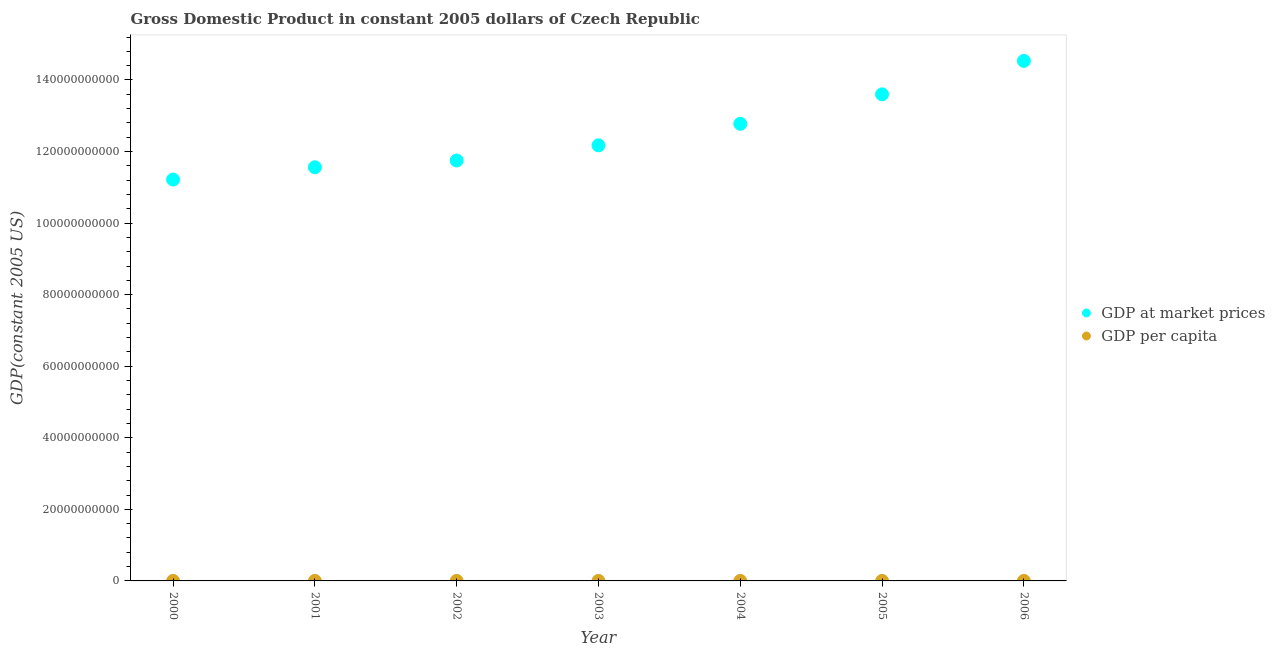How many different coloured dotlines are there?
Give a very brief answer. 2. Is the number of dotlines equal to the number of legend labels?
Your answer should be very brief. Yes. What is the gdp per capita in 2003?
Ensure brevity in your answer.  1.19e+04. Across all years, what is the maximum gdp at market prices?
Provide a succinct answer. 1.45e+11. Across all years, what is the minimum gdp per capita?
Make the answer very short. 1.09e+04. In which year was the gdp per capita maximum?
Your response must be concise. 2006. What is the total gdp at market prices in the graph?
Provide a short and direct response. 8.76e+11. What is the difference between the gdp at market prices in 2001 and that in 2006?
Provide a succinct answer. -2.97e+1. What is the difference between the gdp at market prices in 2006 and the gdp per capita in 2005?
Offer a terse response. 1.45e+11. What is the average gdp at market prices per year?
Provide a succinct answer. 1.25e+11. In the year 2006, what is the difference between the gdp at market prices and gdp per capita?
Your answer should be very brief. 1.45e+11. What is the ratio of the gdp per capita in 2002 to that in 2005?
Give a very brief answer. 0.87. What is the difference between the highest and the second highest gdp at market prices?
Your answer should be compact. 9.35e+09. What is the difference between the highest and the lowest gdp per capita?
Offer a very short reply. 3256.3. Is the gdp at market prices strictly less than the gdp per capita over the years?
Offer a very short reply. No. How many dotlines are there?
Give a very brief answer. 2. How many years are there in the graph?
Offer a very short reply. 7. What is the difference between two consecutive major ticks on the Y-axis?
Provide a succinct answer. 2.00e+1. How many legend labels are there?
Give a very brief answer. 2. What is the title of the graph?
Your response must be concise. Gross Domestic Product in constant 2005 dollars of Czech Republic. What is the label or title of the Y-axis?
Your response must be concise. GDP(constant 2005 US). What is the GDP(constant 2005 US) of GDP at market prices in 2000?
Offer a terse response. 1.12e+11. What is the GDP(constant 2005 US) in GDP per capita in 2000?
Give a very brief answer. 1.09e+04. What is the GDP(constant 2005 US) in GDP at market prices in 2001?
Give a very brief answer. 1.16e+11. What is the GDP(constant 2005 US) of GDP per capita in 2001?
Keep it short and to the point. 1.13e+04. What is the GDP(constant 2005 US) of GDP at market prices in 2002?
Provide a short and direct response. 1.18e+11. What is the GDP(constant 2005 US) of GDP per capita in 2002?
Keep it short and to the point. 1.15e+04. What is the GDP(constant 2005 US) of GDP at market prices in 2003?
Your answer should be very brief. 1.22e+11. What is the GDP(constant 2005 US) in GDP per capita in 2003?
Keep it short and to the point. 1.19e+04. What is the GDP(constant 2005 US) of GDP at market prices in 2004?
Ensure brevity in your answer.  1.28e+11. What is the GDP(constant 2005 US) of GDP per capita in 2004?
Make the answer very short. 1.25e+04. What is the GDP(constant 2005 US) in GDP at market prices in 2005?
Provide a succinct answer. 1.36e+11. What is the GDP(constant 2005 US) in GDP per capita in 2005?
Your answer should be very brief. 1.33e+04. What is the GDP(constant 2005 US) of GDP at market prices in 2006?
Provide a short and direct response. 1.45e+11. What is the GDP(constant 2005 US) of GDP per capita in 2006?
Give a very brief answer. 1.42e+04. Across all years, what is the maximum GDP(constant 2005 US) in GDP at market prices?
Give a very brief answer. 1.45e+11. Across all years, what is the maximum GDP(constant 2005 US) of GDP per capita?
Keep it short and to the point. 1.42e+04. Across all years, what is the minimum GDP(constant 2005 US) of GDP at market prices?
Keep it short and to the point. 1.12e+11. Across all years, what is the minimum GDP(constant 2005 US) in GDP per capita?
Offer a terse response. 1.09e+04. What is the total GDP(constant 2005 US) in GDP at market prices in the graph?
Your answer should be compact. 8.76e+11. What is the total GDP(constant 2005 US) in GDP per capita in the graph?
Provide a short and direct response. 8.58e+04. What is the difference between the GDP(constant 2005 US) of GDP at market prices in 2000 and that in 2001?
Offer a terse response. -3.42e+09. What is the difference between the GDP(constant 2005 US) of GDP per capita in 2000 and that in 2001?
Give a very brief answer. -376.23. What is the difference between the GDP(constant 2005 US) in GDP at market prices in 2000 and that in 2002?
Ensure brevity in your answer.  -5.33e+09. What is the difference between the GDP(constant 2005 US) of GDP per capita in 2000 and that in 2002?
Offer a very short reply. -584.79. What is the difference between the GDP(constant 2005 US) in GDP at market prices in 2000 and that in 2003?
Provide a succinct answer. -9.56e+09. What is the difference between the GDP(constant 2005 US) of GDP per capita in 2000 and that in 2003?
Your answer should be compact. -1003.27. What is the difference between the GDP(constant 2005 US) of GDP at market prices in 2000 and that in 2004?
Offer a terse response. -1.56e+1. What is the difference between the GDP(constant 2005 US) in GDP per capita in 2000 and that in 2004?
Your answer should be compact. -1590.28. What is the difference between the GDP(constant 2005 US) in GDP at market prices in 2000 and that in 2005?
Your answer should be very brief. -2.38e+1. What is the difference between the GDP(constant 2005 US) in GDP per capita in 2000 and that in 2005?
Provide a short and direct response. -2379. What is the difference between the GDP(constant 2005 US) in GDP at market prices in 2000 and that in 2006?
Provide a succinct answer. -3.32e+1. What is the difference between the GDP(constant 2005 US) in GDP per capita in 2000 and that in 2006?
Keep it short and to the point. -3256.3. What is the difference between the GDP(constant 2005 US) in GDP at market prices in 2001 and that in 2002?
Your response must be concise. -1.90e+09. What is the difference between the GDP(constant 2005 US) in GDP per capita in 2001 and that in 2002?
Offer a very short reply. -208.56. What is the difference between the GDP(constant 2005 US) of GDP at market prices in 2001 and that in 2003?
Provide a short and direct response. -6.14e+09. What is the difference between the GDP(constant 2005 US) in GDP per capita in 2001 and that in 2003?
Keep it short and to the point. -627.04. What is the difference between the GDP(constant 2005 US) in GDP at market prices in 2001 and that in 2004?
Give a very brief answer. -1.22e+1. What is the difference between the GDP(constant 2005 US) of GDP per capita in 2001 and that in 2004?
Provide a succinct answer. -1214.05. What is the difference between the GDP(constant 2005 US) in GDP at market prices in 2001 and that in 2005?
Keep it short and to the point. -2.04e+1. What is the difference between the GDP(constant 2005 US) in GDP per capita in 2001 and that in 2005?
Offer a terse response. -2002.76. What is the difference between the GDP(constant 2005 US) in GDP at market prices in 2001 and that in 2006?
Keep it short and to the point. -2.97e+1. What is the difference between the GDP(constant 2005 US) of GDP per capita in 2001 and that in 2006?
Give a very brief answer. -2880.07. What is the difference between the GDP(constant 2005 US) of GDP at market prices in 2002 and that in 2003?
Your answer should be compact. -4.23e+09. What is the difference between the GDP(constant 2005 US) of GDP per capita in 2002 and that in 2003?
Make the answer very short. -418.48. What is the difference between the GDP(constant 2005 US) of GDP at market prices in 2002 and that in 2004?
Make the answer very short. -1.03e+1. What is the difference between the GDP(constant 2005 US) in GDP per capita in 2002 and that in 2004?
Your answer should be very brief. -1005.49. What is the difference between the GDP(constant 2005 US) of GDP at market prices in 2002 and that in 2005?
Ensure brevity in your answer.  -1.85e+1. What is the difference between the GDP(constant 2005 US) in GDP per capita in 2002 and that in 2005?
Provide a short and direct response. -1794.21. What is the difference between the GDP(constant 2005 US) of GDP at market prices in 2002 and that in 2006?
Offer a terse response. -2.78e+1. What is the difference between the GDP(constant 2005 US) of GDP per capita in 2002 and that in 2006?
Your response must be concise. -2671.51. What is the difference between the GDP(constant 2005 US) in GDP at market prices in 2003 and that in 2004?
Give a very brief answer. -6.02e+09. What is the difference between the GDP(constant 2005 US) in GDP per capita in 2003 and that in 2004?
Make the answer very short. -587.01. What is the difference between the GDP(constant 2005 US) of GDP at market prices in 2003 and that in 2005?
Offer a very short reply. -1.43e+1. What is the difference between the GDP(constant 2005 US) of GDP per capita in 2003 and that in 2005?
Keep it short and to the point. -1375.73. What is the difference between the GDP(constant 2005 US) of GDP at market prices in 2003 and that in 2006?
Make the answer very short. -2.36e+1. What is the difference between the GDP(constant 2005 US) in GDP per capita in 2003 and that in 2006?
Your answer should be very brief. -2253.04. What is the difference between the GDP(constant 2005 US) of GDP at market prices in 2004 and that in 2005?
Offer a very short reply. -8.23e+09. What is the difference between the GDP(constant 2005 US) of GDP per capita in 2004 and that in 2005?
Offer a very short reply. -788.72. What is the difference between the GDP(constant 2005 US) in GDP at market prices in 2004 and that in 2006?
Keep it short and to the point. -1.76e+1. What is the difference between the GDP(constant 2005 US) of GDP per capita in 2004 and that in 2006?
Your answer should be compact. -1666.03. What is the difference between the GDP(constant 2005 US) in GDP at market prices in 2005 and that in 2006?
Your response must be concise. -9.35e+09. What is the difference between the GDP(constant 2005 US) in GDP per capita in 2005 and that in 2006?
Ensure brevity in your answer.  -877.31. What is the difference between the GDP(constant 2005 US) of GDP at market prices in 2000 and the GDP(constant 2005 US) of GDP per capita in 2001?
Your response must be concise. 1.12e+11. What is the difference between the GDP(constant 2005 US) in GDP at market prices in 2000 and the GDP(constant 2005 US) in GDP per capita in 2002?
Make the answer very short. 1.12e+11. What is the difference between the GDP(constant 2005 US) of GDP at market prices in 2000 and the GDP(constant 2005 US) of GDP per capita in 2003?
Ensure brevity in your answer.  1.12e+11. What is the difference between the GDP(constant 2005 US) of GDP at market prices in 2000 and the GDP(constant 2005 US) of GDP per capita in 2004?
Keep it short and to the point. 1.12e+11. What is the difference between the GDP(constant 2005 US) in GDP at market prices in 2000 and the GDP(constant 2005 US) in GDP per capita in 2005?
Provide a succinct answer. 1.12e+11. What is the difference between the GDP(constant 2005 US) of GDP at market prices in 2000 and the GDP(constant 2005 US) of GDP per capita in 2006?
Offer a very short reply. 1.12e+11. What is the difference between the GDP(constant 2005 US) of GDP at market prices in 2001 and the GDP(constant 2005 US) of GDP per capita in 2002?
Your response must be concise. 1.16e+11. What is the difference between the GDP(constant 2005 US) of GDP at market prices in 2001 and the GDP(constant 2005 US) of GDP per capita in 2003?
Provide a succinct answer. 1.16e+11. What is the difference between the GDP(constant 2005 US) in GDP at market prices in 2001 and the GDP(constant 2005 US) in GDP per capita in 2004?
Make the answer very short. 1.16e+11. What is the difference between the GDP(constant 2005 US) of GDP at market prices in 2001 and the GDP(constant 2005 US) of GDP per capita in 2005?
Provide a short and direct response. 1.16e+11. What is the difference between the GDP(constant 2005 US) of GDP at market prices in 2001 and the GDP(constant 2005 US) of GDP per capita in 2006?
Your response must be concise. 1.16e+11. What is the difference between the GDP(constant 2005 US) in GDP at market prices in 2002 and the GDP(constant 2005 US) in GDP per capita in 2003?
Your response must be concise. 1.18e+11. What is the difference between the GDP(constant 2005 US) in GDP at market prices in 2002 and the GDP(constant 2005 US) in GDP per capita in 2004?
Provide a short and direct response. 1.18e+11. What is the difference between the GDP(constant 2005 US) of GDP at market prices in 2002 and the GDP(constant 2005 US) of GDP per capita in 2005?
Provide a short and direct response. 1.18e+11. What is the difference between the GDP(constant 2005 US) in GDP at market prices in 2002 and the GDP(constant 2005 US) in GDP per capita in 2006?
Offer a very short reply. 1.18e+11. What is the difference between the GDP(constant 2005 US) in GDP at market prices in 2003 and the GDP(constant 2005 US) in GDP per capita in 2004?
Your response must be concise. 1.22e+11. What is the difference between the GDP(constant 2005 US) of GDP at market prices in 2003 and the GDP(constant 2005 US) of GDP per capita in 2005?
Give a very brief answer. 1.22e+11. What is the difference between the GDP(constant 2005 US) of GDP at market prices in 2003 and the GDP(constant 2005 US) of GDP per capita in 2006?
Your answer should be compact. 1.22e+11. What is the difference between the GDP(constant 2005 US) of GDP at market prices in 2004 and the GDP(constant 2005 US) of GDP per capita in 2005?
Keep it short and to the point. 1.28e+11. What is the difference between the GDP(constant 2005 US) of GDP at market prices in 2004 and the GDP(constant 2005 US) of GDP per capita in 2006?
Your answer should be compact. 1.28e+11. What is the difference between the GDP(constant 2005 US) in GDP at market prices in 2005 and the GDP(constant 2005 US) in GDP per capita in 2006?
Provide a succinct answer. 1.36e+11. What is the average GDP(constant 2005 US) in GDP at market prices per year?
Give a very brief answer. 1.25e+11. What is the average GDP(constant 2005 US) in GDP per capita per year?
Provide a succinct answer. 1.23e+04. In the year 2000, what is the difference between the GDP(constant 2005 US) of GDP at market prices and GDP(constant 2005 US) of GDP per capita?
Offer a terse response. 1.12e+11. In the year 2001, what is the difference between the GDP(constant 2005 US) in GDP at market prices and GDP(constant 2005 US) in GDP per capita?
Offer a very short reply. 1.16e+11. In the year 2002, what is the difference between the GDP(constant 2005 US) of GDP at market prices and GDP(constant 2005 US) of GDP per capita?
Provide a succinct answer. 1.18e+11. In the year 2003, what is the difference between the GDP(constant 2005 US) in GDP at market prices and GDP(constant 2005 US) in GDP per capita?
Keep it short and to the point. 1.22e+11. In the year 2004, what is the difference between the GDP(constant 2005 US) in GDP at market prices and GDP(constant 2005 US) in GDP per capita?
Your answer should be compact. 1.28e+11. In the year 2005, what is the difference between the GDP(constant 2005 US) in GDP at market prices and GDP(constant 2005 US) in GDP per capita?
Offer a terse response. 1.36e+11. In the year 2006, what is the difference between the GDP(constant 2005 US) in GDP at market prices and GDP(constant 2005 US) in GDP per capita?
Ensure brevity in your answer.  1.45e+11. What is the ratio of the GDP(constant 2005 US) in GDP at market prices in 2000 to that in 2001?
Offer a very short reply. 0.97. What is the ratio of the GDP(constant 2005 US) in GDP per capita in 2000 to that in 2001?
Give a very brief answer. 0.97. What is the ratio of the GDP(constant 2005 US) of GDP at market prices in 2000 to that in 2002?
Offer a very short reply. 0.95. What is the ratio of the GDP(constant 2005 US) of GDP per capita in 2000 to that in 2002?
Your response must be concise. 0.95. What is the ratio of the GDP(constant 2005 US) of GDP at market prices in 2000 to that in 2003?
Ensure brevity in your answer.  0.92. What is the ratio of the GDP(constant 2005 US) in GDP per capita in 2000 to that in 2003?
Offer a very short reply. 0.92. What is the ratio of the GDP(constant 2005 US) of GDP at market prices in 2000 to that in 2004?
Keep it short and to the point. 0.88. What is the ratio of the GDP(constant 2005 US) in GDP per capita in 2000 to that in 2004?
Offer a very short reply. 0.87. What is the ratio of the GDP(constant 2005 US) of GDP at market prices in 2000 to that in 2005?
Make the answer very short. 0.82. What is the ratio of the GDP(constant 2005 US) of GDP per capita in 2000 to that in 2005?
Give a very brief answer. 0.82. What is the ratio of the GDP(constant 2005 US) of GDP at market prices in 2000 to that in 2006?
Give a very brief answer. 0.77. What is the ratio of the GDP(constant 2005 US) of GDP per capita in 2000 to that in 2006?
Make the answer very short. 0.77. What is the ratio of the GDP(constant 2005 US) of GDP at market prices in 2001 to that in 2002?
Make the answer very short. 0.98. What is the ratio of the GDP(constant 2005 US) of GDP per capita in 2001 to that in 2002?
Ensure brevity in your answer.  0.98. What is the ratio of the GDP(constant 2005 US) of GDP at market prices in 2001 to that in 2003?
Offer a terse response. 0.95. What is the ratio of the GDP(constant 2005 US) in GDP per capita in 2001 to that in 2003?
Keep it short and to the point. 0.95. What is the ratio of the GDP(constant 2005 US) of GDP at market prices in 2001 to that in 2004?
Your response must be concise. 0.9. What is the ratio of the GDP(constant 2005 US) in GDP per capita in 2001 to that in 2004?
Your response must be concise. 0.9. What is the ratio of the GDP(constant 2005 US) of GDP at market prices in 2001 to that in 2005?
Provide a short and direct response. 0.85. What is the ratio of the GDP(constant 2005 US) in GDP per capita in 2001 to that in 2005?
Give a very brief answer. 0.85. What is the ratio of the GDP(constant 2005 US) in GDP at market prices in 2001 to that in 2006?
Your answer should be compact. 0.8. What is the ratio of the GDP(constant 2005 US) of GDP per capita in 2001 to that in 2006?
Offer a very short reply. 0.8. What is the ratio of the GDP(constant 2005 US) in GDP at market prices in 2002 to that in 2003?
Make the answer very short. 0.97. What is the ratio of the GDP(constant 2005 US) in GDP at market prices in 2002 to that in 2004?
Offer a very short reply. 0.92. What is the ratio of the GDP(constant 2005 US) in GDP per capita in 2002 to that in 2004?
Your answer should be compact. 0.92. What is the ratio of the GDP(constant 2005 US) of GDP at market prices in 2002 to that in 2005?
Provide a short and direct response. 0.86. What is the ratio of the GDP(constant 2005 US) of GDP per capita in 2002 to that in 2005?
Offer a terse response. 0.87. What is the ratio of the GDP(constant 2005 US) in GDP at market prices in 2002 to that in 2006?
Your response must be concise. 0.81. What is the ratio of the GDP(constant 2005 US) in GDP per capita in 2002 to that in 2006?
Make the answer very short. 0.81. What is the ratio of the GDP(constant 2005 US) of GDP at market prices in 2003 to that in 2004?
Make the answer very short. 0.95. What is the ratio of the GDP(constant 2005 US) of GDP per capita in 2003 to that in 2004?
Your answer should be compact. 0.95. What is the ratio of the GDP(constant 2005 US) in GDP at market prices in 2003 to that in 2005?
Your answer should be very brief. 0.9. What is the ratio of the GDP(constant 2005 US) of GDP per capita in 2003 to that in 2005?
Keep it short and to the point. 0.9. What is the ratio of the GDP(constant 2005 US) of GDP at market prices in 2003 to that in 2006?
Your answer should be very brief. 0.84. What is the ratio of the GDP(constant 2005 US) in GDP per capita in 2003 to that in 2006?
Make the answer very short. 0.84. What is the ratio of the GDP(constant 2005 US) in GDP at market prices in 2004 to that in 2005?
Your answer should be very brief. 0.94. What is the ratio of the GDP(constant 2005 US) of GDP per capita in 2004 to that in 2005?
Your answer should be very brief. 0.94. What is the ratio of the GDP(constant 2005 US) of GDP at market prices in 2004 to that in 2006?
Offer a terse response. 0.88. What is the ratio of the GDP(constant 2005 US) of GDP per capita in 2004 to that in 2006?
Your answer should be compact. 0.88. What is the ratio of the GDP(constant 2005 US) in GDP at market prices in 2005 to that in 2006?
Your response must be concise. 0.94. What is the ratio of the GDP(constant 2005 US) in GDP per capita in 2005 to that in 2006?
Your answer should be very brief. 0.94. What is the difference between the highest and the second highest GDP(constant 2005 US) in GDP at market prices?
Keep it short and to the point. 9.35e+09. What is the difference between the highest and the second highest GDP(constant 2005 US) in GDP per capita?
Your response must be concise. 877.31. What is the difference between the highest and the lowest GDP(constant 2005 US) in GDP at market prices?
Your answer should be very brief. 3.32e+1. What is the difference between the highest and the lowest GDP(constant 2005 US) in GDP per capita?
Make the answer very short. 3256.3. 